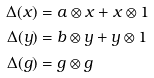Convert formula to latex. <formula><loc_0><loc_0><loc_500><loc_500>\Delta ( x ) & = a \otimes x + x \otimes 1 \\ \Delta ( y ) & = b \otimes y + y \otimes 1 \\ \Delta ( g ) & = g \otimes g</formula> 